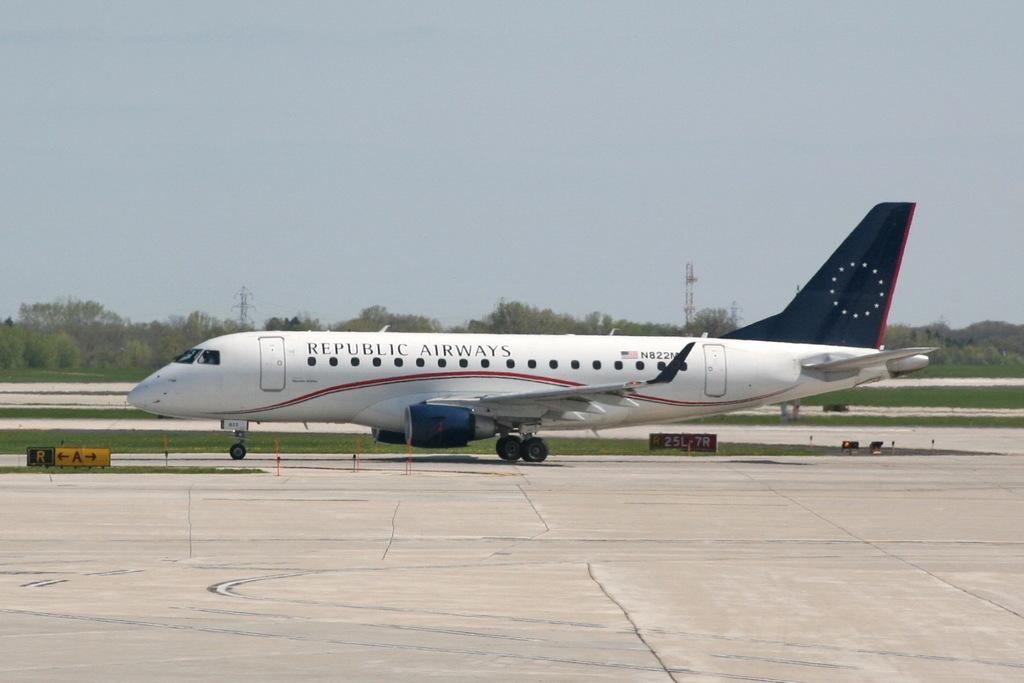Provide a one-sentence caption for the provided image. A white and blue airplane on the running that says Republic Airways. 